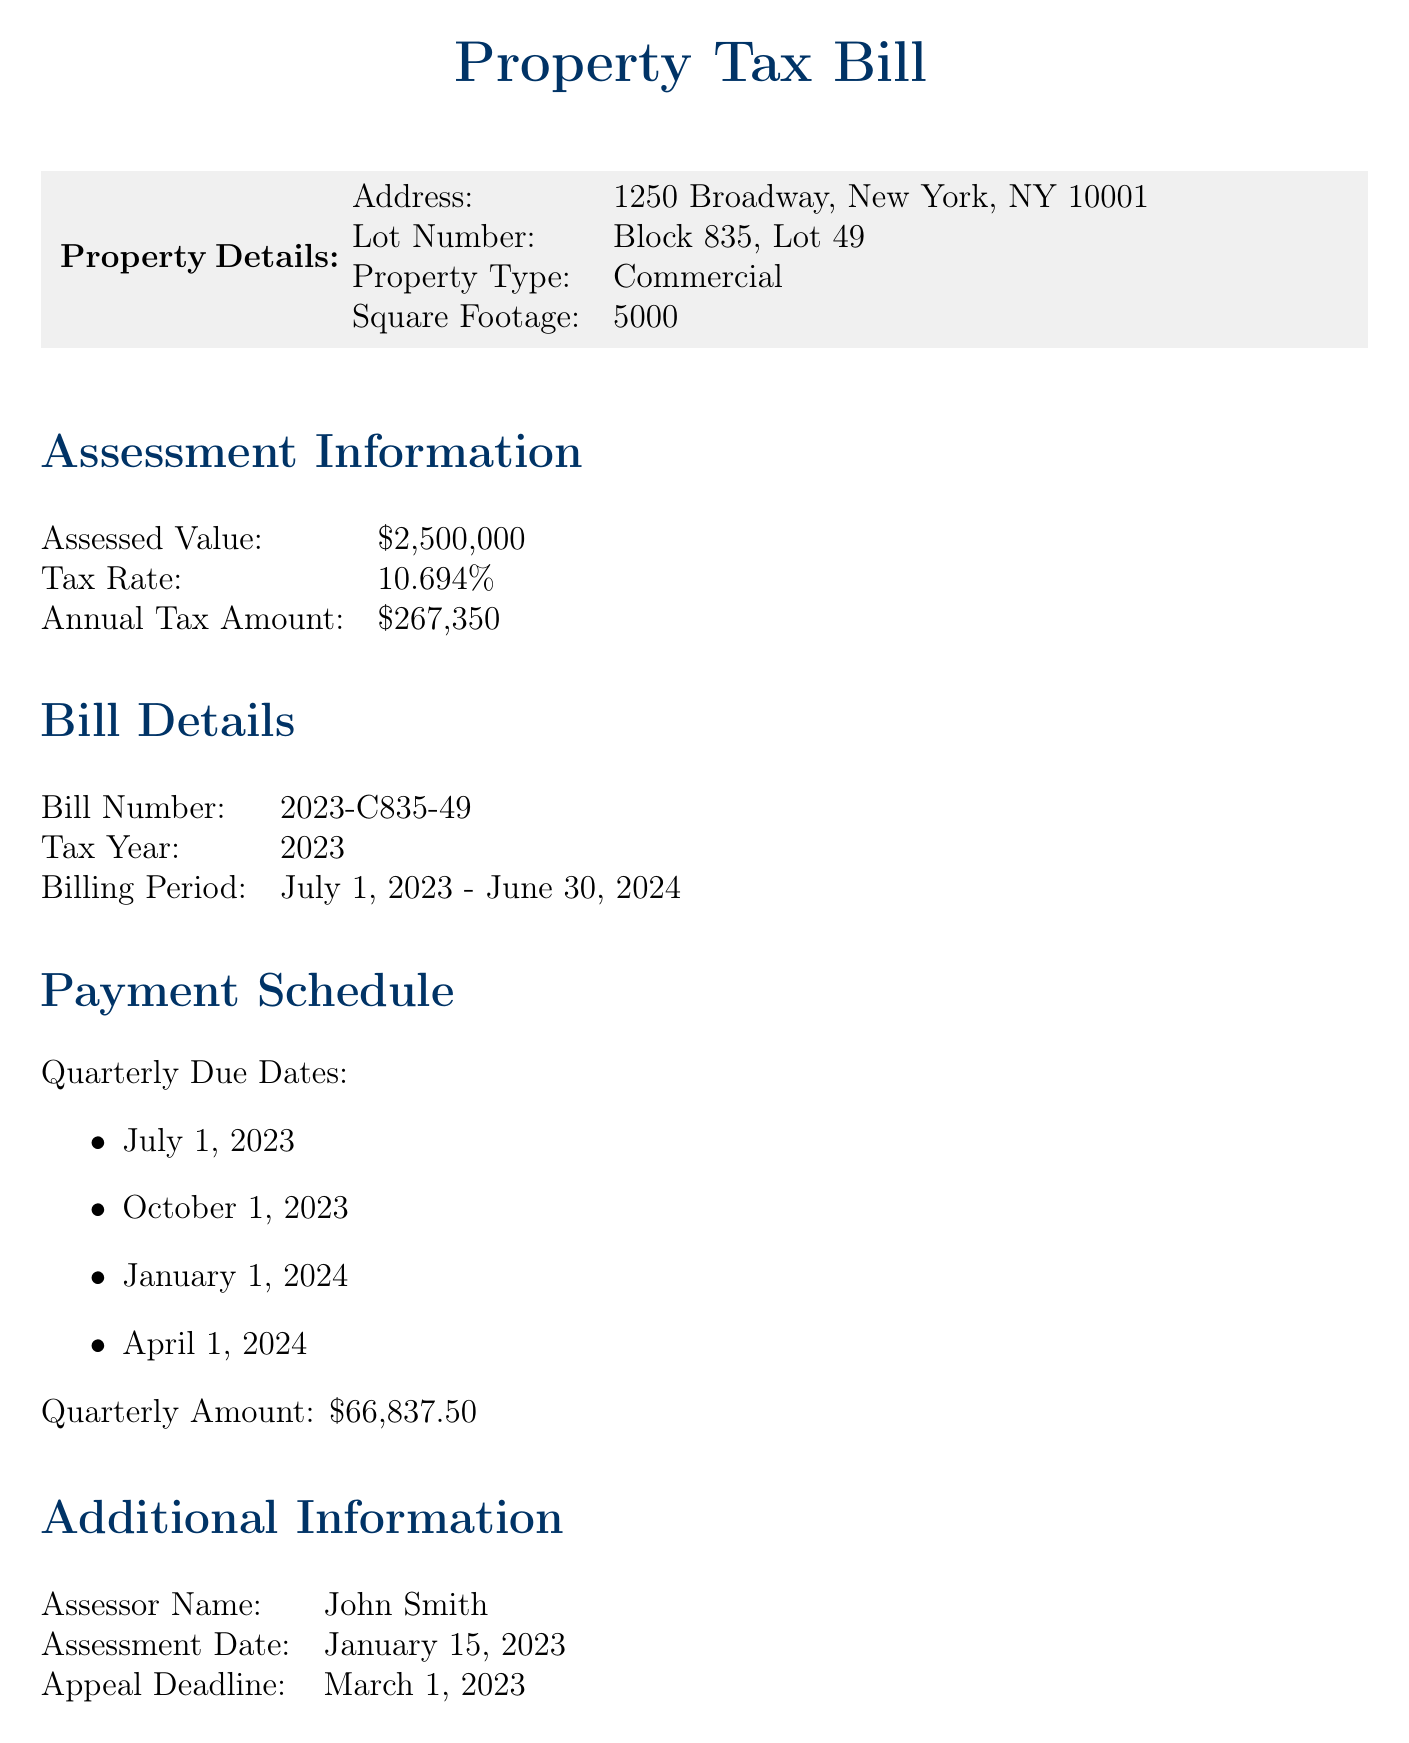What is the address of the property? The address can be found in the property details section of the document.
Answer: 1250 Broadway, New York, NY 10001 What is the assessed value of the property? The assessed value is reported under the assessment information section.
Answer: $2,500,000 What is the annual tax amount? The annual tax amount is listed in the assessment information section.
Answer: $267,350 What is the tax rate? The tax rate is provided in the assessment information section of the document.
Answer: 10.694% When is the appeal deadline? The appeal deadline can be found in the additional information section.
Answer: March 1, 2023 How many quarterly payments are there? The payment schedule lists specific due dates indicating the number of payments.
Answer: 4 What is the quarterly payment amount? The quarterly payment amount is specified in the payment schedule section.
Answer: $66,837.50 What is the tax year for this bill? The tax year is mentioned under the bill details section.
Answer: 2023 Who is the assessor? The assessor's name is provided in the additional information section.
Answer: John Smith 